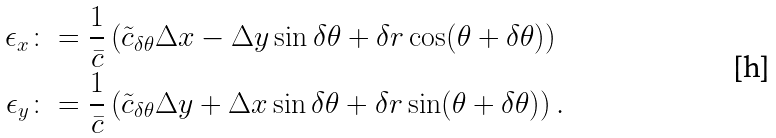Convert formula to latex. <formula><loc_0><loc_0><loc_500><loc_500>\epsilon _ { x } & \colon = \frac { 1 } { \bar { c } } \left ( \tilde { c } _ { \delta \theta } \Delta x - \Delta y \sin \delta \theta + \delta r \cos ( \theta + \delta \theta ) \right ) \\ \epsilon _ { y } & \colon = \frac { 1 } { \bar { c } } \left ( \tilde { c } _ { \delta \theta } \Delta y + \Delta x \sin \delta \theta + \delta r \sin ( \theta + \delta \theta ) \right ) .</formula> 